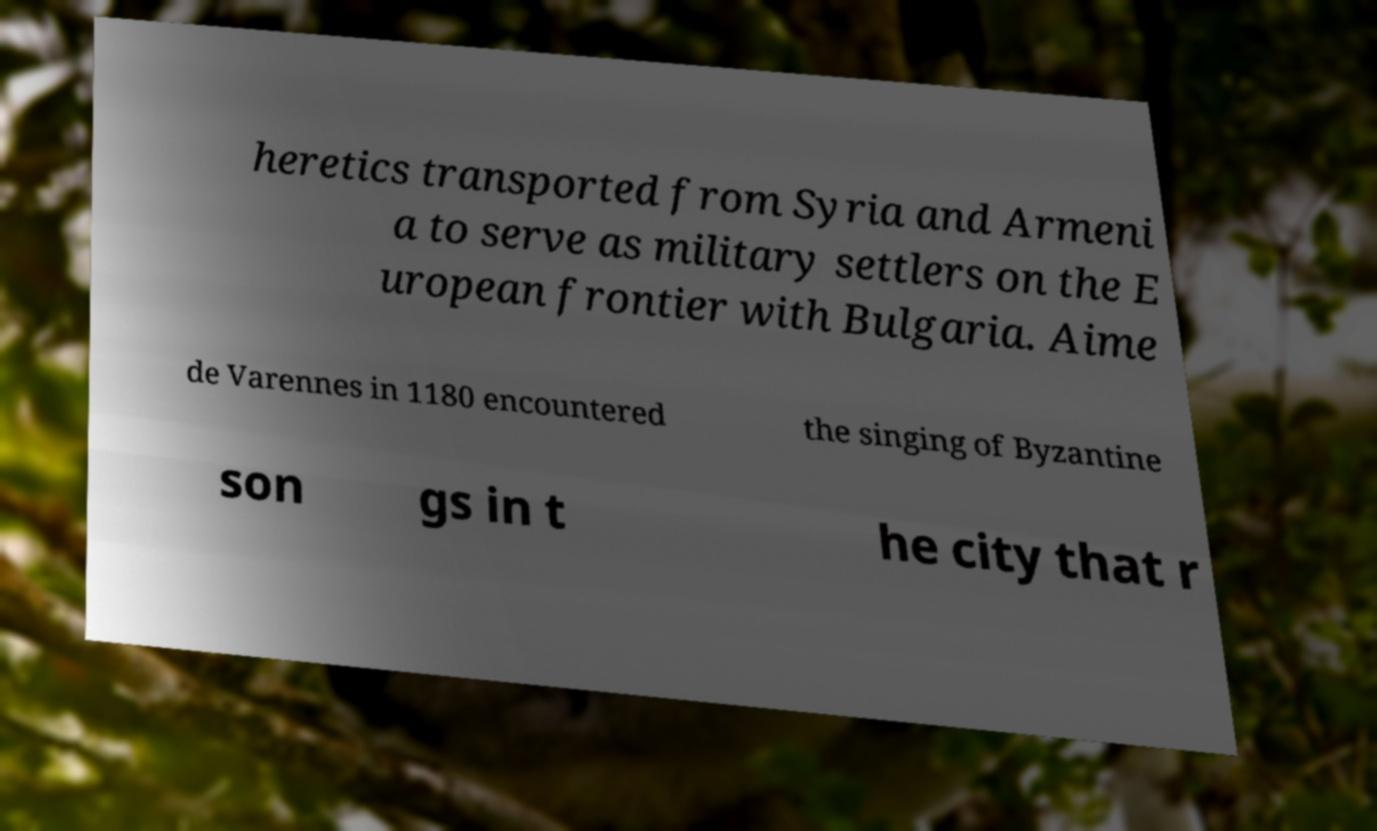There's text embedded in this image that I need extracted. Can you transcribe it verbatim? heretics transported from Syria and Armeni a to serve as military settlers on the E uropean frontier with Bulgaria. Aime de Varennes in 1180 encountered the singing of Byzantine son gs in t he city that r 